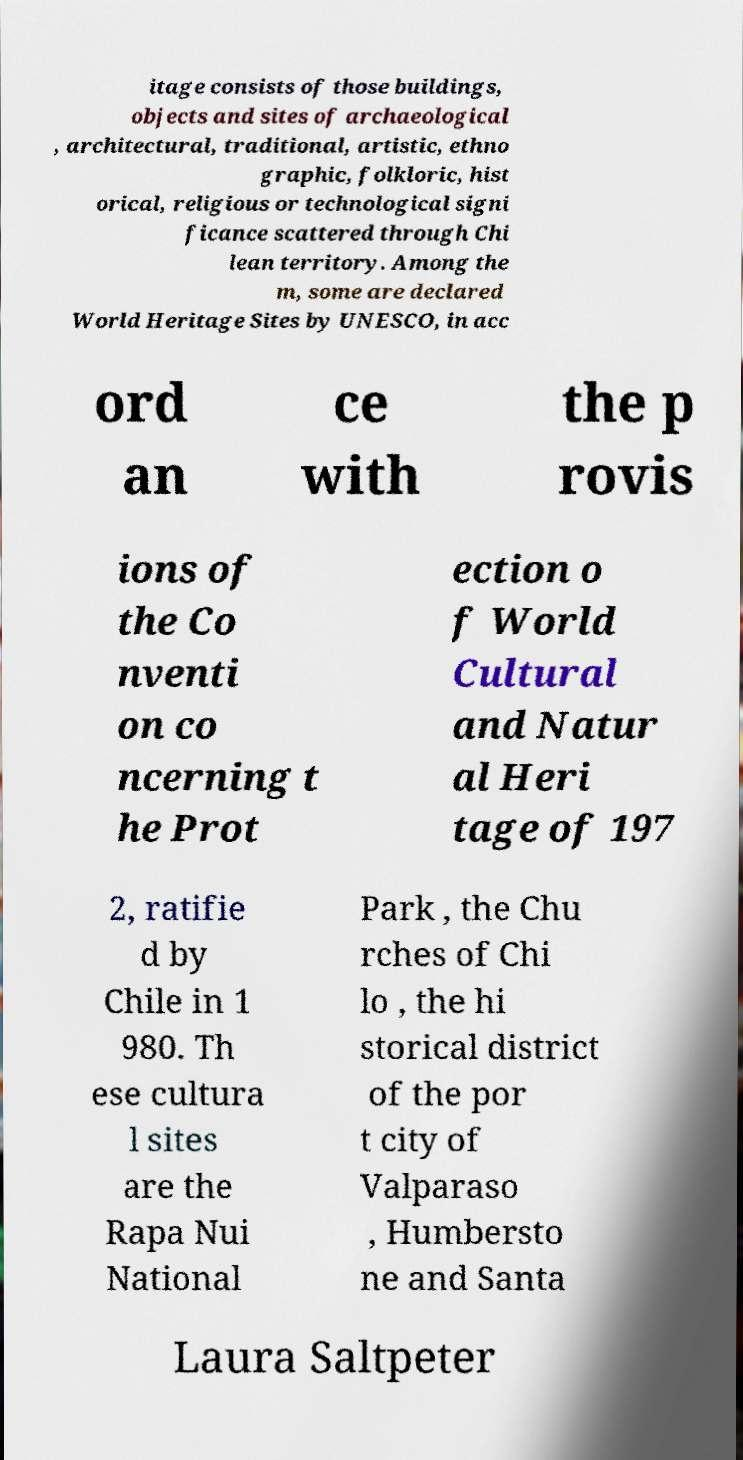For documentation purposes, I need the text within this image transcribed. Could you provide that? itage consists of those buildings, objects and sites of archaeological , architectural, traditional, artistic, ethno graphic, folkloric, hist orical, religious or technological signi ficance scattered through Chi lean territory. Among the m, some are declared World Heritage Sites by UNESCO, in acc ord an ce with the p rovis ions of the Co nventi on co ncerning t he Prot ection o f World Cultural and Natur al Heri tage of 197 2, ratifie d by Chile in 1 980. Th ese cultura l sites are the Rapa Nui National Park , the Chu rches of Chi lo , the hi storical district of the por t city of Valparaso , Humbersto ne and Santa Laura Saltpeter 